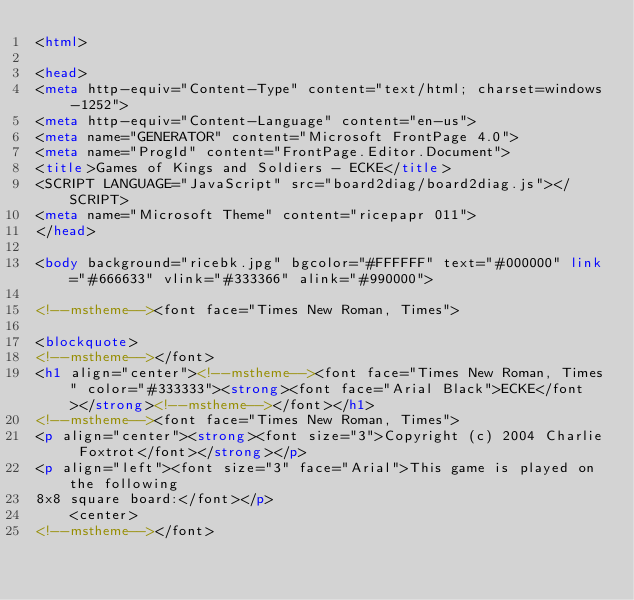Convert code to text. <code><loc_0><loc_0><loc_500><loc_500><_HTML_><html>

<head>
<meta http-equiv="Content-Type" content="text/html; charset=windows-1252">
<meta http-equiv="Content-Language" content="en-us">
<meta name="GENERATOR" content="Microsoft FrontPage 4.0">
<meta name="ProgId" content="FrontPage.Editor.Document">
<title>Games of Kings and Soldiers - ECKE</title>
<SCRIPT LANGUAGE="JavaScript" src="board2diag/board2diag.js"></SCRIPT>
<meta name="Microsoft Theme" content="ricepapr 011">
</head>

<body background="ricebk.jpg" bgcolor="#FFFFFF" text="#000000" link="#666633" vlink="#333366" alink="#990000">

<!--mstheme--><font face="Times New Roman, Times">

<blockquote>
<!--mstheme--></font>
<h1 align="center"><!--mstheme--><font face="Times New Roman, Times" color="#333333"><strong><font face="Arial Black">ECKE</font></strong><!--mstheme--></font></h1>
<!--mstheme--><font face="Times New Roman, Times">
<p align="center"><strong><font size="3">Copyright (c) 2004 Charlie Foxtrot</font></strong></p>
<p align="left"><font size="3" face="Arial">This game is played on the following
8x8 square board:</font></p>
    <center>
<!--mstheme--></font></code> 